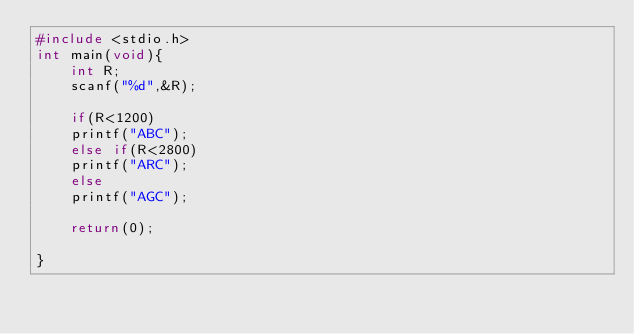<code> <loc_0><loc_0><loc_500><loc_500><_C_>#include <stdio.h>
int main(void){
    int R;
    scanf("%d",&R);
    
    if(R<1200)
    printf("ABC");
    else if(R<2800)
    printf("ARC");
    else
    printf("AGC");
    
    return(0);
    
}
</code> 